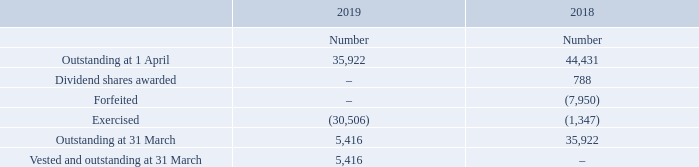Irish SIP
The weighted average market value per ordinary share for Irish SIP options exercised in 2019 was 350.0p (2018: 387.5p). The SIP shares outstanding at 31 March 2018 have fully vested (2018: had a weighted average remaining vesting period of 0.1 years). Options exercised prior to the vesting date relate to those attributable to good leavers as defined by the scheme rules.
What was the weighted average market value per ordinary share for Irish SIP options exercised in 2019? 350.0p. What do the Options exercised prior to the vesting date relate to? Those attributable to good leavers as defined by the scheme rules. For which years was the amount Outstanding at 31 March calculated? 2019, 2018. In which year was the amount Outstanding at 1 April larger? 44,431>35,922
Answer: 2018. What was the change in the amount Outstanding at 1 April in 2019 from 2018? 35,922-44,431
Answer: -8509. What was the percentage change in the amount Outstanding at 1 April in 2019 from 2018?
Answer scale should be: percent. (35,922-44,431)/44,431
Answer: -19.15. 